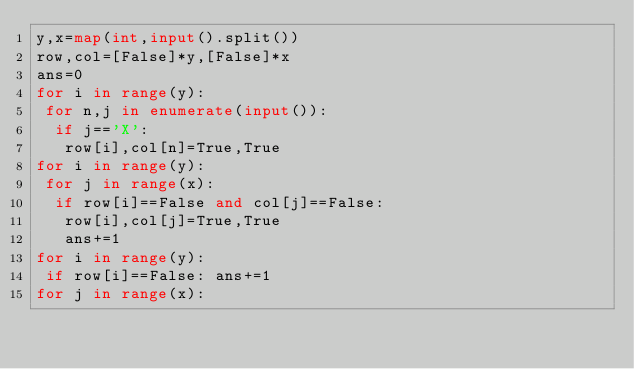Convert code to text. <code><loc_0><loc_0><loc_500><loc_500><_Python_>y,x=map(int,input().split())
row,col=[False]*y,[False]*x
ans=0
for i in range(y):
 for n,j in enumerate(input()):
  if j=='X':
   row[i],col[n]=True,True
for i in range(y):
 for j in range(x):
  if row[i]==False and col[j]==False:
   row[i],col[j]=True,True
   ans+=1
for i in range(y):
 if row[i]==False: ans+=1
for j in range(x):</code> 